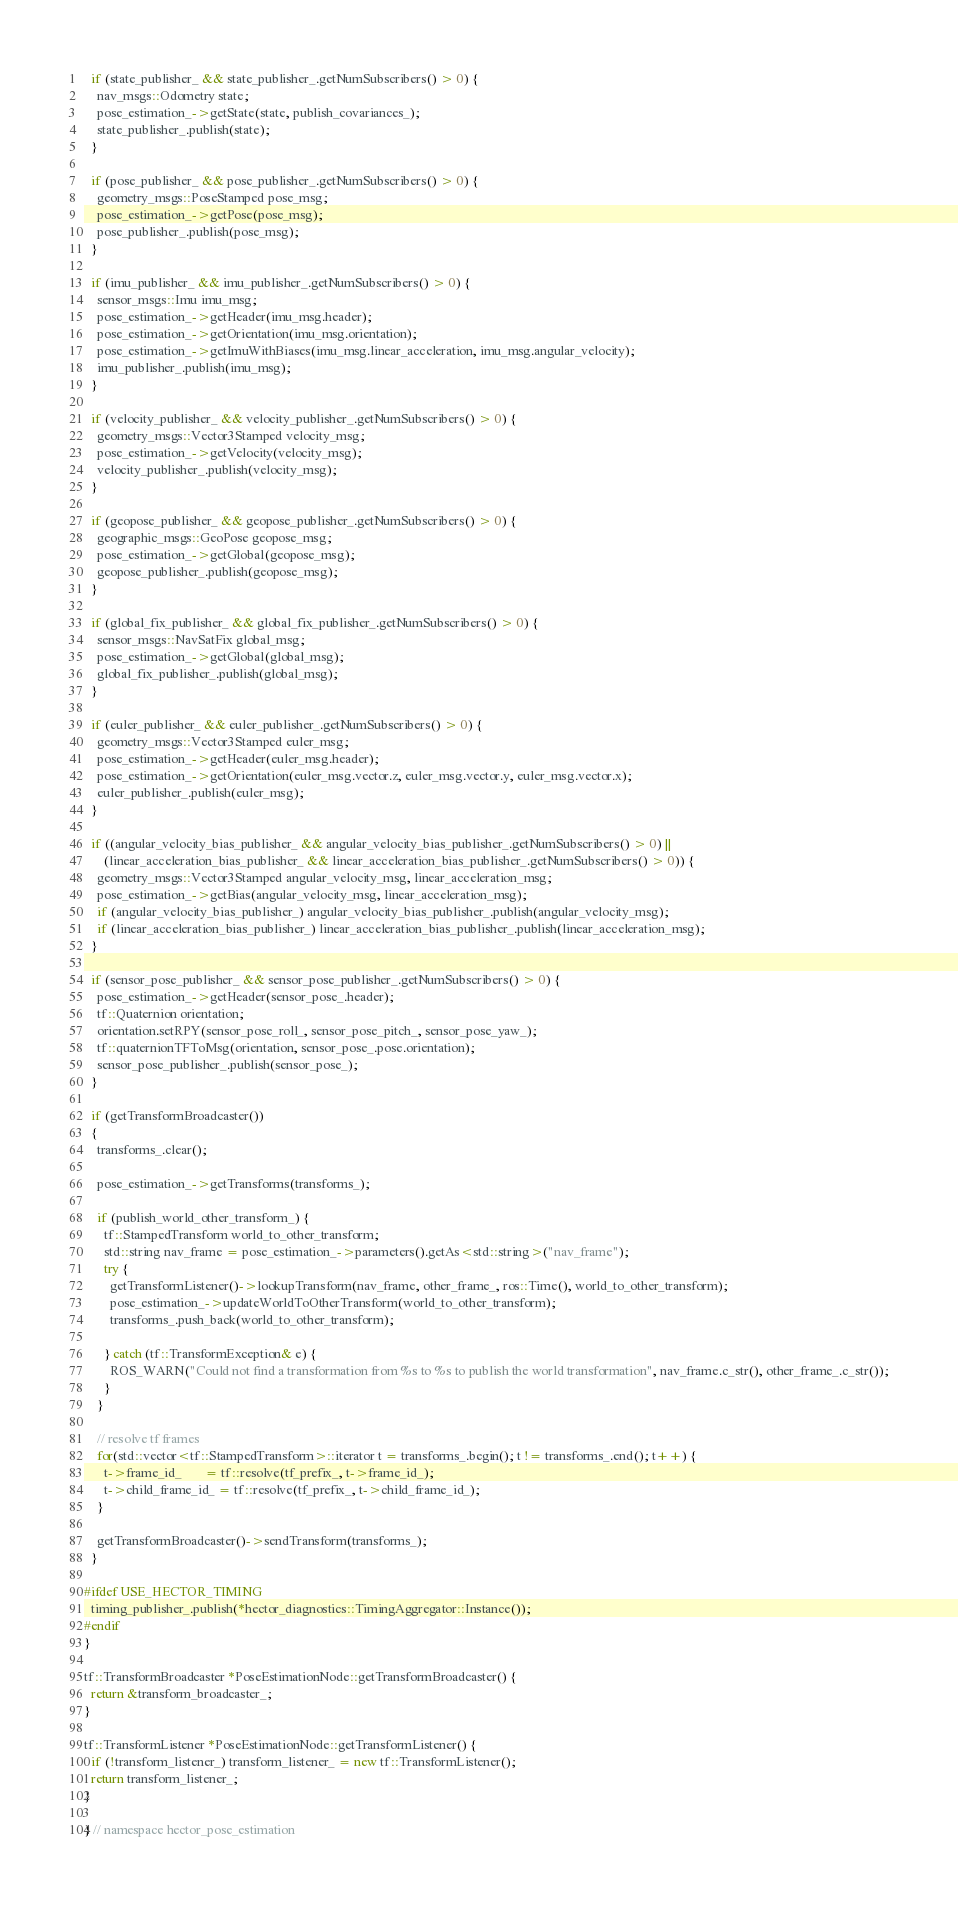Convert code to text. <code><loc_0><loc_0><loc_500><loc_500><_C++_>  if (state_publisher_ && state_publisher_.getNumSubscribers() > 0) {
    nav_msgs::Odometry state;
    pose_estimation_->getState(state, publish_covariances_);
    state_publisher_.publish(state);
  }

  if (pose_publisher_ && pose_publisher_.getNumSubscribers() > 0) {
    geometry_msgs::PoseStamped pose_msg;
    pose_estimation_->getPose(pose_msg);
    pose_publisher_.publish(pose_msg);
  }

  if (imu_publisher_ && imu_publisher_.getNumSubscribers() > 0) {
    sensor_msgs::Imu imu_msg;
    pose_estimation_->getHeader(imu_msg.header);
    pose_estimation_->getOrientation(imu_msg.orientation);
    pose_estimation_->getImuWithBiases(imu_msg.linear_acceleration, imu_msg.angular_velocity);
    imu_publisher_.publish(imu_msg);
  }

  if (velocity_publisher_ && velocity_publisher_.getNumSubscribers() > 0) {
    geometry_msgs::Vector3Stamped velocity_msg;
    pose_estimation_->getVelocity(velocity_msg);
    velocity_publisher_.publish(velocity_msg);
  }

  if (geopose_publisher_ && geopose_publisher_.getNumSubscribers() > 0) {
    geographic_msgs::GeoPose geopose_msg;
    pose_estimation_->getGlobal(geopose_msg);
    geopose_publisher_.publish(geopose_msg);
  }

  if (global_fix_publisher_ && global_fix_publisher_.getNumSubscribers() > 0) {
    sensor_msgs::NavSatFix global_msg;
    pose_estimation_->getGlobal(global_msg);
    global_fix_publisher_.publish(global_msg);
  }

  if (euler_publisher_ && euler_publisher_.getNumSubscribers() > 0) {
    geometry_msgs::Vector3Stamped euler_msg;
    pose_estimation_->getHeader(euler_msg.header);
    pose_estimation_->getOrientation(euler_msg.vector.z, euler_msg.vector.y, euler_msg.vector.x);
    euler_publisher_.publish(euler_msg);
  }

  if ((angular_velocity_bias_publisher_ && angular_velocity_bias_publisher_.getNumSubscribers() > 0) ||
      (linear_acceleration_bias_publisher_ && linear_acceleration_bias_publisher_.getNumSubscribers() > 0)) {
    geometry_msgs::Vector3Stamped angular_velocity_msg, linear_acceleration_msg;
    pose_estimation_->getBias(angular_velocity_msg, linear_acceleration_msg);
    if (angular_velocity_bias_publisher_) angular_velocity_bias_publisher_.publish(angular_velocity_msg);
    if (linear_acceleration_bias_publisher_) linear_acceleration_bias_publisher_.publish(linear_acceleration_msg);
  }

  if (sensor_pose_publisher_ && sensor_pose_publisher_.getNumSubscribers() > 0) {
    pose_estimation_->getHeader(sensor_pose_.header);
    tf::Quaternion orientation;
    orientation.setRPY(sensor_pose_roll_, sensor_pose_pitch_, sensor_pose_yaw_);
    tf::quaternionTFToMsg(orientation, sensor_pose_.pose.orientation);
    sensor_pose_publisher_.publish(sensor_pose_);
  }

  if (getTransformBroadcaster())
  {
    transforms_.clear();

    pose_estimation_->getTransforms(transforms_);

    if (publish_world_other_transform_) {
      tf::StampedTransform world_to_other_transform;
      std::string nav_frame = pose_estimation_->parameters().getAs<std::string>("nav_frame");
      try {
        getTransformListener()->lookupTransform(nav_frame, other_frame_, ros::Time(), world_to_other_transform);
        pose_estimation_->updateWorldToOtherTransform(world_to_other_transform);
        transforms_.push_back(world_to_other_transform);

      } catch (tf::TransformException& e) {
        ROS_WARN("Could not find a transformation from %s to %s to publish the world transformation", nav_frame.c_str(), other_frame_.c_str());
      }
    }

    // resolve tf frames
    for(std::vector<tf::StampedTransform>::iterator t = transforms_.begin(); t != transforms_.end(); t++) {
      t->frame_id_       = tf::resolve(tf_prefix_, t->frame_id_);
      t->child_frame_id_ = tf::resolve(tf_prefix_, t->child_frame_id_);
    }

    getTransformBroadcaster()->sendTransform(transforms_);
  }

#ifdef USE_HECTOR_TIMING
  timing_publisher_.publish(*hector_diagnostics::TimingAggregator::Instance());
#endif
}

tf::TransformBroadcaster *PoseEstimationNode::getTransformBroadcaster() {
  return &transform_broadcaster_;
}

tf::TransformListener *PoseEstimationNode::getTransformListener() {
  if (!transform_listener_) transform_listener_ = new tf::TransformListener();
  return transform_listener_;
}

} // namespace hector_pose_estimation
</code> 